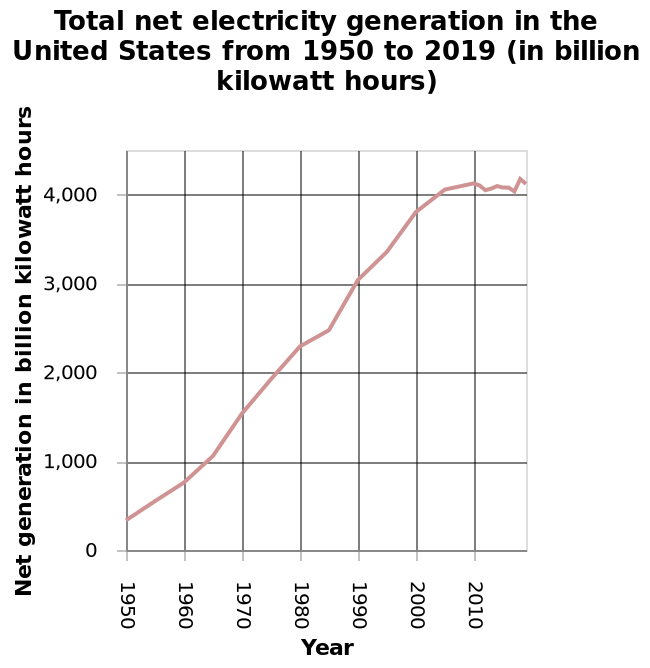<image>
What is the range of the x-axis?  The range of the x-axis is from 1950 to 2010, represented in years. Describe the following image in detail This is a line chart titled Total net electricity generation in the United States from 1950 to 2019 (in billion kilowatt hours). The y-axis shows Net generation in billion kilowatt hours with linear scale from 0 to 4,000 while the x-axis plots Year as linear scale from 1950 to 2010. What is the scale of the y-axis?  The scale of the y-axis is linear, ranging from 0 to 4,000 billion kilowatt hours. Is the range of the x-axis from 1950 to 2010, represented in months? No. The range of the x-axis is from 1950 to 2010, represented in years. 